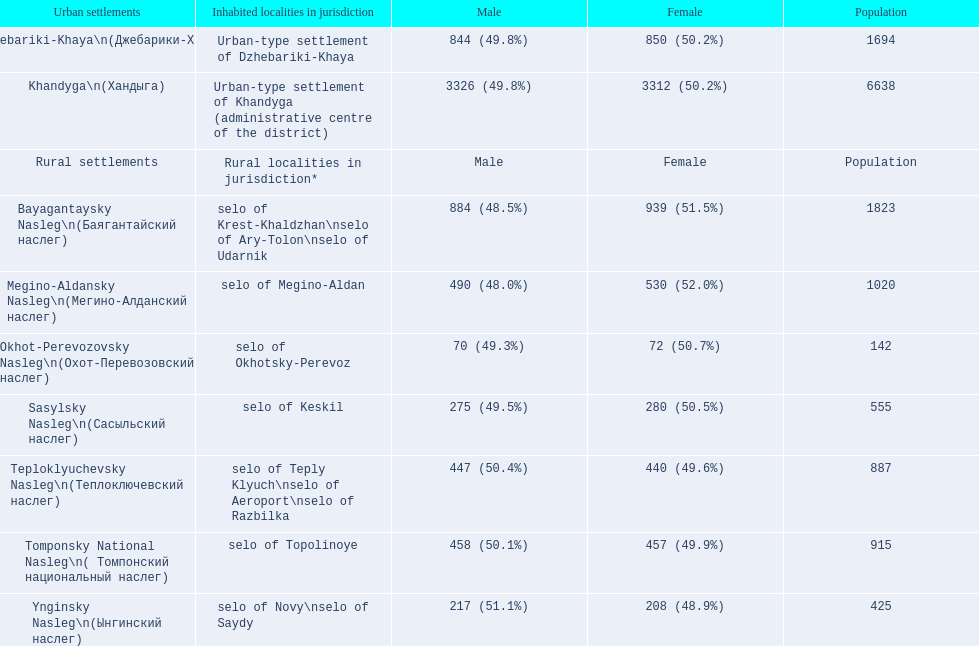Could you parse the entire table as a dict? {'header': ['Urban settlements', 'Inhabited localities in jurisdiction', 'Male', 'Female', 'Population'], 'rows': [['Dzhebariki-Khaya\\n(Джебарики-Хая)', 'Urban-type settlement of Dzhebariki-Khaya', '844 (49.8%)', '850 (50.2%)', '1694'], ['Khandyga\\n(Хандыга)', 'Urban-type settlement of Khandyga (administrative centre of the district)', '3326 (49.8%)', '3312 (50.2%)', '6638'], ['Rural settlements', 'Rural localities in jurisdiction*', 'Male', 'Female', 'Population'], ['Bayagantaysky Nasleg\\n(Баягантайский наслег)', 'selo of Krest-Khaldzhan\\nselo of Ary-Tolon\\nselo of Udarnik', '884 (48.5%)', '939 (51.5%)', '1823'], ['Megino-Aldansky Nasleg\\n(Мегино-Алданский наслег)', 'selo of Megino-Aldan', '490 (48.0%)', '530 (52.0%)', '1020'], ['Okhot-Perevozovsky Nasleg\\n(Охот-Перевозовский наслег)', 'selo of Okhotsky-Perevoz', '70 (49.3%)', '72 (50.7%)', '142'], ['Sasylsky Nasleg\\n(Сасыльский наслег)', 'selo of Keskil', '275 (49.5%)', '280 (50.5%)', '555'], ['Teploklyuchevsky Nasleg\\n(Теплоключевский наслег)', 'selo of Teply Klyuch\\nselo of Aeroport\\nselo of Razbilka', '447 (50.4%)', '440 (49.6%)', '887'], ['Tomponsky National Nasleg\\n( Томпонский национальный наслег)', 'selo of Topolinoye', '458 (50.1%)', '457 (49.9%)', '915'], ['Ynginsky Nasleg\\n(Ынгинский наслег)', 'selo of Novy\\nselo of Saydy', '217 (51.1%)', '208 (48.9%)', '425']]} How many cities have a population under 1000? 5. 